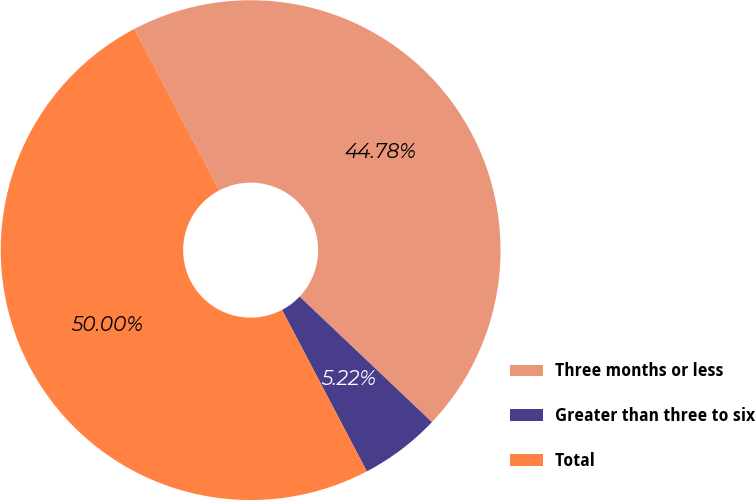Convert chart. <chart><loc_0><loc_0><loc_500><loc_500><pie_chart><fcel>Three months or less<fcel>Greater than three to six<fcel>Total<nl><fcel>44.78%<fcel>5.22%<fcel>50.0%<nl></chart> 